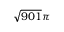Convert formula to latex. <formula><loc_0><loc_0><loc_500><loc_500>\sqrt { 9 0 1 } \pi</formula> 